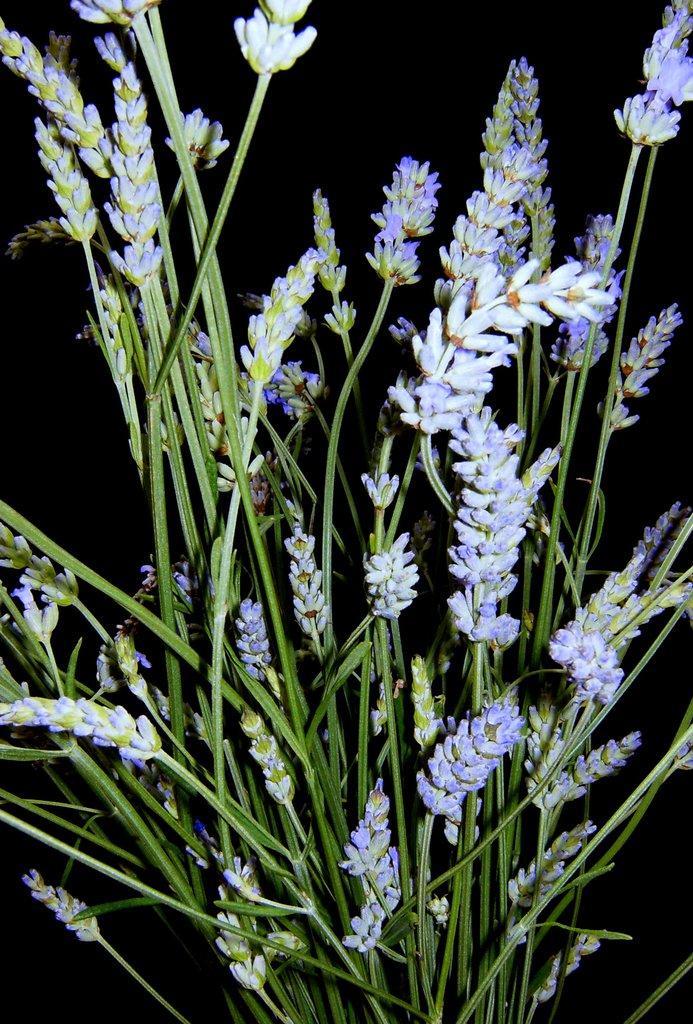How would you summarize this image in a sentence or two? In this picture we can see a plant along with flowers. 